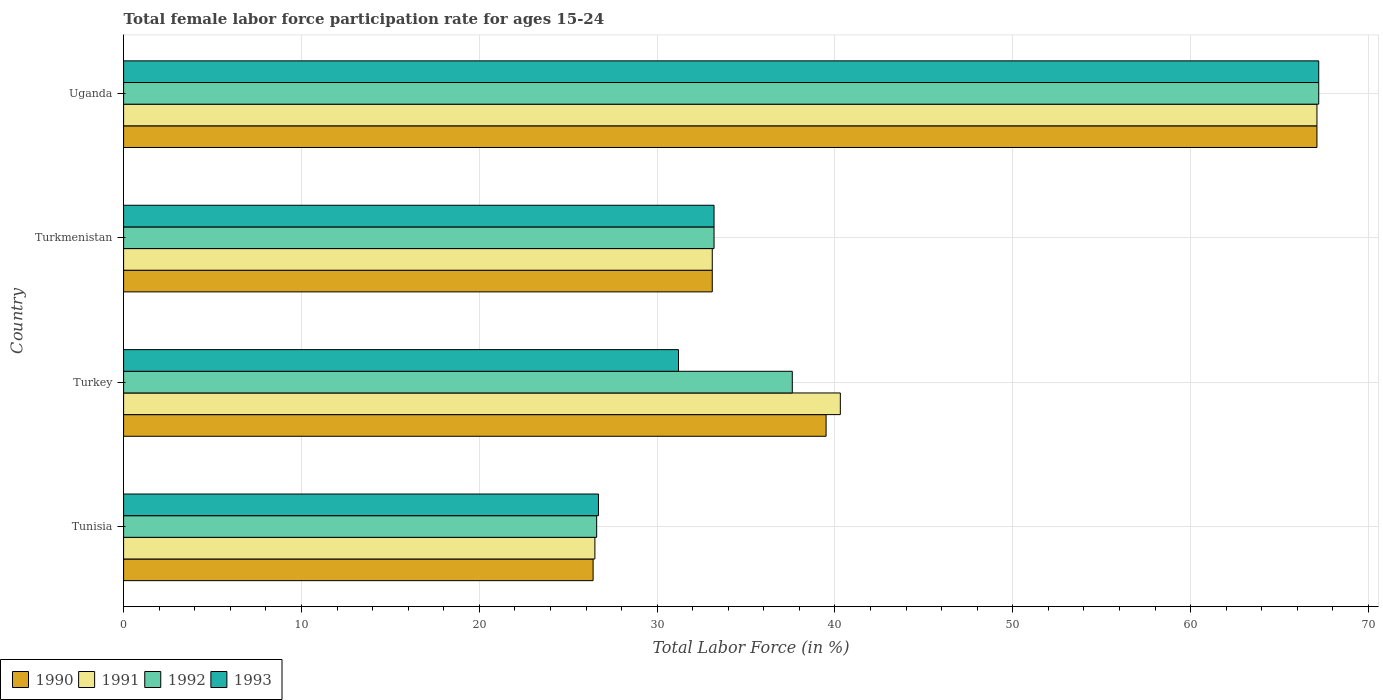Are the number of bars per tick equal to the number of legend labels?
Offer a terse response. Yes. What is the label of the 2nd group of bars from the top?
Make the answer very short. Turkmenistan. What is the female labor force participation rate in 1991 in Uganda?
Give a very brief answer. 67.1. Across all countries, what is the maximum female labor force participation rate in 1991?
Your answer should be compact. 67.1. Across all countries, what is the minimum female labor force participation rate in 1990?
Provide a succinct answer. 26.4. In which country was the female labor force participation rate in 1992 maximum?
Your answer should be compact. Uganda. In which country was the female labor force participation rate in 1993 minimum?
Offer a terse response. Tunisia. What is the total female labor force participation rate in 1991 in the graph?
Give a very brief answer. 167. What is the difference between the female labor force participation rate in 1990 in Tunisia and that in Turkmenistan?
Make the answer very short. -6.7. What is the difference between the female labor force participation rate in 1992 in Uganda and the female labor force participation rate in 1990 in Turkmenistan?
Ensure brevity in your answer.  34.1. What is the average female labor force participation rate in 1992 per country?
Ensure brevity in your answer.  41.15. What is the difference between the female labor force participation rate in 1990 and female labor force participation rate in 1993 in Tunisia?
Give a very brief answer. -0.3. What is the ratio of the female labor force participation rate in 1991 in Tunisia to that in Uganda?
Your response must be concise. 0.39. What is the difference between the highest and the second highest female labor force participation rate in 1990?
Your answer should be compact. 27.6. What is the difference between the highest and the lowest female labor force participation rate in 1993?
Make the answer very short. 40.5. In how many countries, is the female labor force participation rate in 1990 greater than the average female labor force participation rate in 1990 taken over all countries?
Provide a succinct answer. 1. What does the 4th bar from the bottom in Tunisia represents?
Ensure brevity in your answer.  1993. Are all the bars in the graph horizontal?
Your answer should be very brief. Yes. What is the difference between two consecutive major ticks on the X-axis?
Your answer should be very brief. 10. Does the graph contain any zero values?
Your response must be concise. No. Does the graph contain grids?
Your answer should be very brief. Yes. Where does the legend appear in the graph?
Your answer should be compact. Bottom left. What is the title of the graph?
Make the answer very short. Total female labor force participation rate for ages 15-24. Does "2005" appear as one of the legend labels in the graph?
Your response must be concise. No. What is the label or title of the X-axis?
Give a very brief answer. Total Labor Force (in %). What is the Total Labor Force (in %) in 1990 in Tunisia?
Your response must be concise. 26.4. What is the Total Labor Force (in %) in 1992 in Tunisia?
Provide a succinct answer. 26.6. What is the Total Labor Force (in %) of 1993 in Tunisia?
Ensure brevity in your answer.  26.7. What is the Total Labor Force (in %) in 1990 in Turkey?
Ensure brevity in your answer.  39.5. What is the Total Labor Force (in %) in 1991 in Turkey?
Give a very brief answer. 40.3. What is the Total Labor Force (in %) of 1992 in Turkey?
Make the answer very short. 37.6. What is the Total Labor Force (in %) of 1993 in Turkey?
Provide a succinct answer. 31.2. What is the Total Labor Force (in %) in 1990 in Turkmenistan?
Ensure brevity in your answer.  33.1. What is the Total Labor Force (in %) in 1991 in Turkmenistan?
Give a very brief answer. 33.1. What is the Total Labor Force (in %) in 1992 in Turkmenistan?
Offer a terse response. 33.2. What is the Total Labor Force (in %) in 1993 in Turkmenistan?
Make the answer very short. 33.2. What is the Total Labor Force (in %) in 1990 in Uganda?
Make the answer very short. 67.1. What is the Total Labor Force (in %) in 1991 in Uganda?
Provide a short and direct response. 67.1. What is the Total Labor Force (in %) in 1992 in Uganda?
Your answer should be compact. 67.2. What is the Total Labor Force (in %) in 1993 in Uganda?
Offer a terse response. 67.2. Across all countries, what is the maximum Total Labor Force (in %) of 1990?
Your answer should be very brief. 67.1. Across all countries, what is the maximum Total Labor Force (in %) of 1991?
Your response must be concise. 67.1. Across all countries, what is the maximum Total Labor Force (in %) of 1992?
Provide a succinct answer. 67.2. Across all countries, what is the maximum Total Labor Force (in %) in 1993?
Your answer should be compact. 67.2. Across all countries, what is the minimum Total Labor Force (in %) in 1990?
Keep it short and to the point. 26.4. Across all countries, what is the minimum Total Labor Force (in %) in 1991?
Give a very brief answer. 26.5. Across all countries, what is the minimum Total Labor Force (in %) of 1992?
Keep it short and to the point. 26.6. Across all countries, what is the minimum Total Labor Force (in %) in 1993?
Provide a succinct answer. 26.7. What is the total Total Labor Force (in %) of 1990 in the graph?
Give a very brief answer. 166.1. What is the total Total Labor Force (in %) in 1991 in the graph?
Your answer should be compact. 167. What is the total Total Labor Force (in %) in 1992 in the graph?
Give a very brief answer. 164.6. What is the total Total Labor Force (in %) of 1993 in the graph?
Provide a succinct answer. 158.3. What is the difference between the Total Labor Force (in %) in 1991 in Tunisia and that in Turkey?
Your answer should be compact. -13.8. What is the difference between the Total Labor Force (in %) of 1992 in Tunisia and that in Turkey?
Ensure brevity in your answer.  -11. What is the difference between the Total Labor Force (in %) in 1990 in Tunisia and that in Turkmenistan?
Ensure brevity in your answer.  -6.7. What is the difference between the Total Labor Force (in %) of 1991 in Tunisia and that in Turkmenistan?
Offer a very short reply. -6.6. What is the difference between the Total Labor Force (in %) in 1992 in Tunisia and that in Turkmenistan?
Your answer should be very brief. -6.6. What is the difference between the Total Labor Force (in %) of 1990 in Tunisia and that in Uganda?
Your response must be concise. -40.7. What is the difference between the Total Labor Force (in %) in 1991 in Tunisia and that in Uganda?
Your response must be concise. -40.6. What is the difference between the Total Labor Force (in %) in 1992 in Tunisia and that in Uganda?
Offer a terse response. -40.6. What is the difference between the Total Labor Force (in %) in 1993 in Tunisia and that in Uganda?
Provide a short and direct response. -40.5. What is the difference between the Total Labor Force (in %) in 1990 in Turkey and that in Turkmenistan?
Keep it short and to the point. 6.4. What is the difference between the Total Labor Force (in %) in 1991 in Turkey and that in Turkmenistan?
Offer a very short reply. 7.2. What is the difference between the Total Labor Force (in %) in 1990 in Turkey and that in Uganda?
Make the answer very short. -27.6. What is the difference between the Total Labor Force (in %) in 1991 in Turkey and that in Uganda?
Offer a terse response. -26.8. What is the difference between the Total Labor Force (in %) in 1992 in Turkey and that in Uganda?
Offer a terse response. -29.6. What is the difference between the Total Labor Force (in %) in 1993 in Turkey and that in Uganda?
Make the answer very short. -36. What is the difference between the Total Labor Force (in %) in 1990 in Turkmenistan and that in Uganda?
Provide a succinct answer. -34. What is the difference between the Total Labor Force (in %) of 1991 in Turkmenistan and that in Uganda?
Keep it short and to the point. -34. What is the difference between the Total Labor Force (in %) of 1992 in Turkmenistan and that in Uganda?
Offer a terse response. -34. What is the difference between the Total Labor Force (in %) of 1993 in Turkmenistan and that in Uganda?
Offer a terse response. -34. What is the difference between the Total Labor Force (in %) in 1990 in Tunisia and the Total Labor Force (in %) in 1991 in Turkey?
Give a very brief answer. -13.9. What is the difference between the Total Labor Force (in %) in 1990 in Tunisia and the Total Labor Force (in %) in 1993 in Turkey?
Your answer should be compact. -4.8. What is the difference between the Total Labor Force (in %) of 1991 in Tunisia and the Total Labor Force (in %) of 1992 in Turkey?
Provide a short and direct response. -11.1. What is the difference between the Total Labor Force (in %) of 1991 in Tunisia and the Total Labor Force (in %) of 1993 in Turkey?
Make the answer very short. -4.7. What is the difference between the Total Labor Force (in %) in 1992 in Tunisia and the Total Labor Force (in %) in 1993 in Turkey?
Ensure brevity in your answer.  -4.6. What is the difference between the Total Labor Force (in %) in 1990 in Tunisia and the Total Labor Force (in %) in 1991 in Turkmenistan?
Offer a very short reply. -6.7. What is the difference between the Total Labor Force (in %) in 1990 in Tunisia and the Total Labor Force (in %) in 1992 in Turkmenistan?
Provide a short and direct response. -6.8. What is the difference between the Total Labor Force (in %) of 1990 in Tunisia and the Total Labor Force (in %) of 1993 in Turkmenistan?
Your answer should be compact. -6.8. What is the difference between the Total Labor Force (in %) in 1991 in Tunisia and the Total Labor Force (in %) in 1993 in Turkmenistan?
Ensure brevity in your answer.  -6.7. What is the difference between the Total Labor Force (in %) in 1990 in Tunisia and the Total Labor Force (in %) in 1991 in Uganda?
Offer a terse response. -40.7. What is the difference between the Total Labor Force (in %) of 1990 in Tunisia and the Total Labor Force (in %) of 1992 in Uganda?
Your response must be concise. -40.8. What is the difference between the Total Labor Force (in %) in 1990 in Tunisia and the Total Labor Force (in %) in 1993 in Uganda?
Give a very brief answer. -40.8. What is the difference between the Total Labor Force (in %) in 1991 in Tunisia and the Total Labor Force (in %) in 1992 in Uganda?
Ensure brevity in your answer.  -40.7. What is the difference between the Total Labor Force (in %) in 1991 in Tunisia and the Total Labor Force (in %) in 1993 in Uganda?
Make the answer very short. -40.7. What is the difference between the Total Labor Force (in %) in 1992 in Tunisia and the Total Labor Force (in %) in 1993 in Uganda?
Your answer should be compact. -40.6. What is the difference between the Total Labor Force (in %) of 1990 in Turkey and the Total Labor Force (in %) of 1991 in Turkmenistan?
Ensure brevity in your answer.  6.4. What is the difference between the Total Labor Force (in %) in 1990 in Turkey and the Total Labor Force (in %) in 1992 in Turkmenistan?
Keep it short and to the point. 6.3. What is the difference between the Total Labor Force (in %) of 1990 in Turkey and the Total Labor Force (in %) of 1993 in Turkmenistan?
Offer a very short reply. 6.3. What is the difference between the Total Labor Force (in %) in 1991 in Turkey and the Total Labor Force (in %) in 1992 in Turkmenistan?
Provide a short and direct response. 7.1. What is the difference between the Total Labor Force (in %) of 1991 in Turkey and the Total Labor Force (in %) of 1993 in Turkmenistan?
Your answer should be compact. 7.1. What is the difference between the Total Labor Force (in %) in 1990 in Turkey and the Total Labor Force (in %) in 1991 in Uganda?
Provide a succinct answer. -27.6. What is the difference between the Total Labor Force (in %) of 1990 in Turkey and the Total Labor Force (in %) of 1992 in Uganda?
Offer a very short reply. -27.7. What is the difference between the Total Labor Force (in %) in 1990 in Turkey and the Total Labor Force (in %) in 1993 in Uganda?
Provide a short and direct response. -27.7. What is the difference between the Total Labor Force (in %) in 1991 in Turkey and the Total Labor Force (in %) in 1992 in Uganda?
Give a very brief answer. -26.9. What is the difference between the Total Labor Force (in %) in 1991 in Turkey and the Total Labor Force (in %) in 1993 in Uganda?
Provide a short and direct response. -26.9. What is the difference between the Total Labor Force (in %) of 1992 in Turkey and the Total Labor Force (in %) of 1993 in Uganda?
Your answer should be very brief. -29.6. What is the difference between the Total Labor Force (in %) in 1990 in Turkmenistan and the Total Labor Force (in %) in 1991 in Uganda?
Ensure brevity in your answer.  -34. What is the difference between the Total Labor Force (in %) in 1990 in Turkmenistan and the Total Labor Force (in %) in 1992 in Uganda?
Give a very brief answer. -34.1. What is the difference between the Total Labor Force (in %) in 1990 in Turkmenistan and the Total Labor Force (in %) in 1993 in Uganda?
Give a very brief answer. -34.1. What is the difference between the Total Labor Force (in %) of 1991 in Turkmenistan and the Total Labor Force (in %) of 1992 in Uganda?
Your answer should be very brief. -34.1. What is the difference between the Total Labor Force (in %) of 1991 in Turkmenistan and the Total Labor Force (in %) of 1993 in Uganda?
Provide a short and direct response. -34.1. What is the difference between the Total Labor Force (in %) in 1992 in Turkmenistan and the Total Labor Force (in %) in 1993 in Uganda?
Offer a very short reply. -34. What is the average Total Labor Force (in %) of 1990 per country?
Your answer should be compact. 41.52. What is the average Total Labor Force (in %) of 1991 per country?
Your response must be concise. 41.75. What is the average Total Labor Force (in %) in 1992 per country?
Keep it short and to the point. 41.15. What is the average Total Labor Force (in %) of 1993 per country?
Ensure brevity in your answer.  39.58. What is the difference between the Total Labor Force (in %) in 1990 and Total Labor Force (in %) in 1992 in Tunisia?
Your response must be concise. -0.2. What is the difference between the Total Labor Force (in %) of 1990 and Total Labor Force (in %) of 1993 in Tunisia?
Your response must be concise. -0.3. What is the difference between the Total Labor Force (in %) of 1991 and Total Labor Force (in %) of 1992 in Tunisia?
Your answer should be very brief. -0.1. What is the difference between the Total Labor Force (in %) of 1992 and Total Labor Force (in %) of 1993 in Tunisia?
Offer a very short reply. -0.1. What is the difference between the Total Labor Force (in %) in 1990 and Total Labor Force (in %) in 1991 in Turkey?
Provide a short and direct response. -0.8. What is the difference between the Total Labor Force (in %) of 1990 and Total Labor Force (in %) of 1992 in Turkey?
Your answer should be compact. 1.9. What is the difference between the Total Labor Force (in %) in 1991 and Total Labor Force (in %) in 1993 in Turkey?
Provide a succinct answer. 9.1. What is the difference between the Total Labor Force (in %) in 1991 and Total Labor Force (in %) in 1992 in Turkmenistan?
Ensure brevity in your answer.  -0.1. What is the difference between the Total Labor Force (in %) of 1992 and Total Labor Force (in %) of 1993 in Turkmenistan?
Your answer should be compact. 0. What is the difference between the Total Labor Force (in %) in 1990 and Total Labor Force (in %) in 1992 in Uganda?
Your answer should be very brief. -0.1. What is the difference between the Total Labor Force (in %) in 1991 and Total Labor Force (in %) in 1992 in Uganda?
Provide a succinct answer. -0.1. What is the difference between the Total Labor Force (in %) of 1991 and Total Labor Force (in %) of 1993 in Uganda?
Give a very brief answer. -0.1. What is the difference between the Total Labor Force (in %) in 1992 and Total Labor Force (in %) in 1993 in Uganda?
Offer a terse response. 0. What is the ratio of the Total Labor Force (in %) of 1990 in Tunisia to that in Turkey?
Ensure brevity in your answer.  0.67. What is the ratio of the Total Labor Force (in %) in 1991 in Tunisia to that in Turkey?
Offer a terse response. 0.66. What is the ratio of the Total Labor Force (in %) in 1992 in Tunisia to that in Turkey?
Your answer should be very brief. 0.71. What is the ratio of the Total Labor Force (in %) of 1993 in Tunisia to that in Turkey?
Provide a short and direct response. 0.86. What is the ratio of the Total Labor Force (in %) of 1990 in Tunisia to that in Turkmenistan?
Make the answer very short. 0.8. What is the ratio of the Total Labor Force (in %) in 1991 in Tunisia to that in Turkmenistan?
Offer a terse response. 0.8. What is the ratio of the Total Labor Force (in %) of 1992 in Tunisia to that in Turkmenistan?
Keep it short and to the point. 0.8. What is the ratio of the Total Labor Force (in %) of 1993 in Tunisia to that in Turkmenistan?
Your answer should be compact. 0.8. What is the ratio of the Total Labor Force (in %) of 1990 in Tunisia to that in Uganda?
Your answer should be very brief. 0.39. What is the ratio of the Total Labor Force (in %) in 1991 in Tunisia to that in Uganda?
Keep it short and to the point. 0.39. What is the ratio of the Total Labor Force (in %) of 1992 in Tunisia to that in Uganda?
Keep it short and to the point. 0.4. What is the ratio of the Total Labor Force (in %) of 1993 in Tunisia to that in Uganda?
Provide a succinct answer. 0.4. What is the ratio of the Total Labor Force (in %) of 1990 in Turkey to that in Turkmenistan?
Offer a terse response. 1.19. What is the ratio of the Total Labor Force (in %) in 1991 in Turkey to that in Turkmenistan?
Give a very brief answer. 1.22. What is the ratio of the Total Labor Force (in %) of 1992 in Turkey to that in Turkmenistan?
Your answer should be compact. 1.13. What is the ratio of the Total Labor Force (in %) of 1993 in Turkey to that in Turkmenistan?
Ensure brevity in your answer.  0.94. What is the ratio of the Total Labor Force (in %) in 1990 in Turkey to that in Uganda?
Your answer should be very brief. 0.59. What is the ratio of the Total Labor Force (in %) in 1991 in Turkey to that in Uganda?
Your answer should be very brief. 0.6. What is the ratio of the Total Labor Force (in %) in 1992 in Turkey to that in Uganda?
Give a very brief answer. 0.56. What is the ratio of the Total Labor Force (in %) in 1993 in Turkey to that in Uganda?
Your answer should be very brief. 0.46. What is the ratio of the Total Labor Force (in %) of 1990 in Turkmenistan to that in Uganda?
Your response must be concise. 0.49. What is the ratio of the Total Labor Force (in %) of 1991 in Turkmenistan to that in Uganda?
Keep it short and to the point. 0.49. What is the ratio of the Total Labor Force (in %) of 1992 in Turkmenistan to that in Uganda?
Your answer should be very brief. 0.49. What is the ratio of the Total Labor Force (in %) in 1993 in Turkmenistan to that in Uganda?
Give a very brief answer. 0.49. What is the difference between the highest and the second highest Total Labor Force (in %) in 1990?
Offer a terse response. 27.6. What is the difference between the highest and the second highest Total Labor Force (in %) in 1991?
Provide a short and direct response. 26.8. What is the difference between the highest and the second highest Total Labor Force (in %) of 1992?
Offer a terse response. 29.6. What is the difference between the highest and the lowest Total Labor Force (in %) in 1990?
Your response must be concise. 40.7. What is the difference between the highest and the lowest Total Labor Force (in %) of 1991?
Offer a very short reply. 40.6. What is the difference between the highest and the lowest Total Labor Force (in %) in 1992?
Keep it short and to the point. 40.6. What is the difference between the highest and the lowest Total Labor Force (in %) in 1993?
Your answer should be very brief. 40.5. 